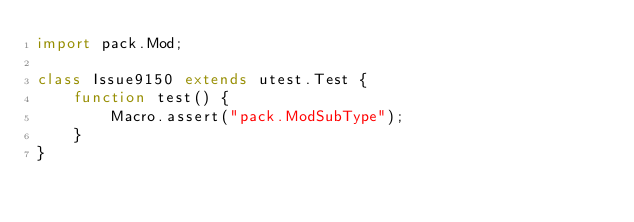Convert code to text. <code><loc_0><loc_0><loc_500><loc_500><_Haxe_>import pack.Mod;

class Issue9150 extends utest.Test {
    function test() {
        Macro.assert("pack.ModSubType");
    }
}
</code> 